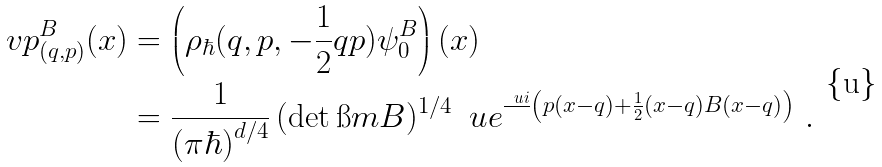<formula> <loc_0><loc_0><loc_500><loc_500>\ v p _ { ( q , p ) } ^ { B } ( x ) & = \left ( \rho _ { \hbar } ( q , p , - \frac { 1 } { 2 } q p ) \psi _ { 0 } ^ { B } \right ) ( x ) \\ & = \frac { 1 } { ( \pi \hbar { ) } ^ { d / 4 } } \, ( \det \i m B ) ^ { 1 / 4 } \, \ u e ^ { \frac { \ u i } { } \left ( p ( x - q ) + \frac { 1 } { 2 } ( x - q ) B ( x - q ) \right ) } \ .</formula> 